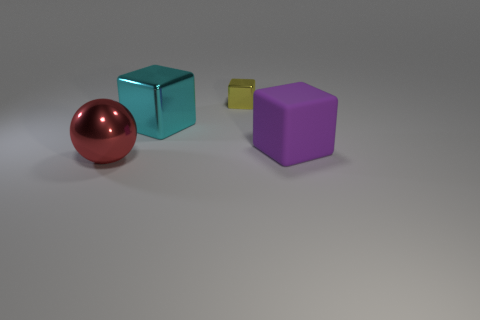Can you describe the colors and shapes of the objects in the image? Certainly! There are four objects in the image. Starting from the left, there's a shiny red sphere, a shiny teal cube, a small yellow cube that appears slightly less shiny, and a matte purple cube. 